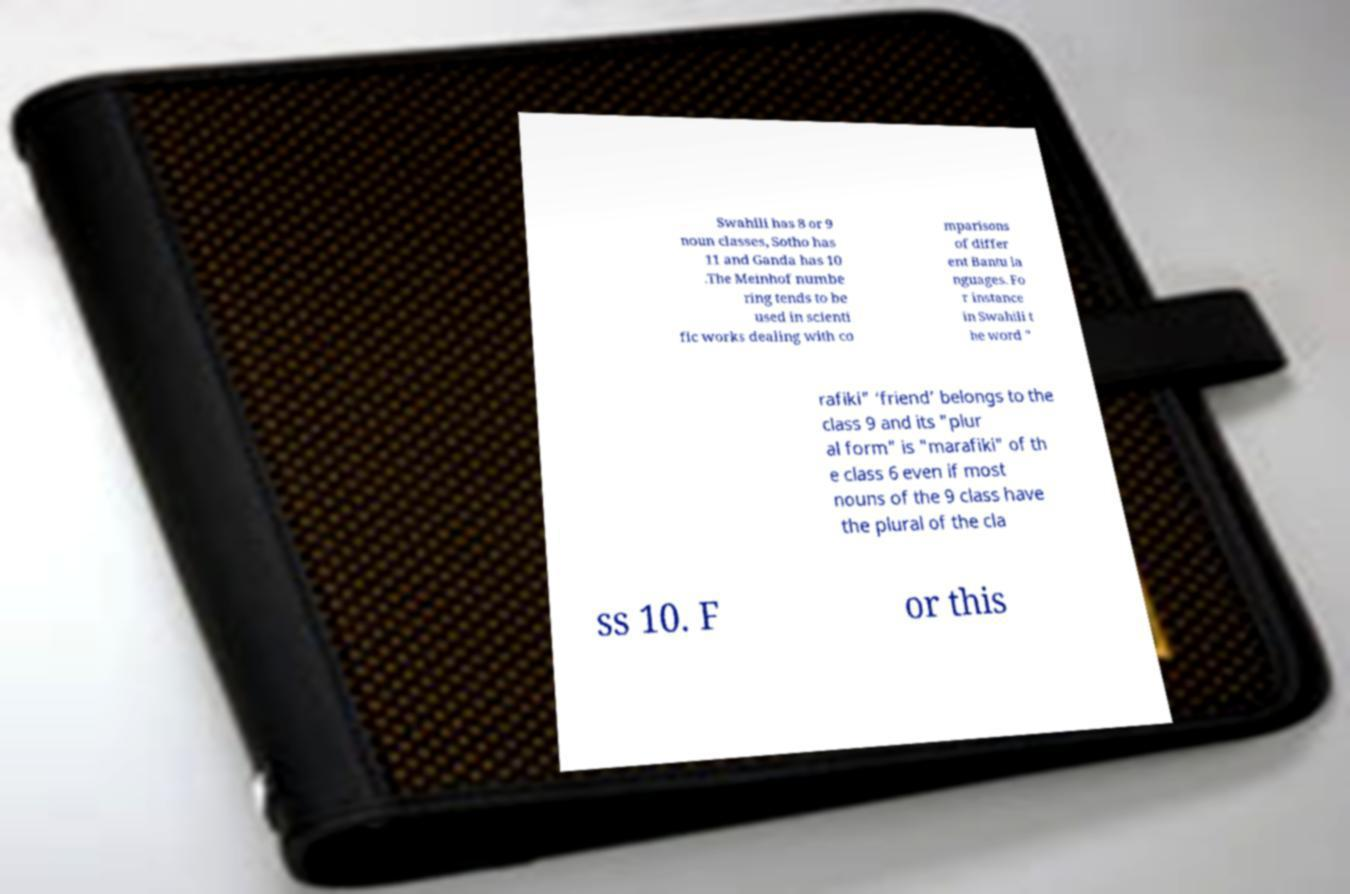Can you read and provide the text displayed in the image?This photo seems to have some interesting text. Can you extract and type it out for me? Swahili has 8 or 9 noun classes, Sotho has 11 and Ganda has 10 .The Meinhof numbe ring tends to be used in scienti fic works dealing with co mparisons of differ ent Bantu la nguages. Fo r instance in Swahili t he word " rafiki" ‘friend’ belongs to the class 9 and its "plur al form" is "marafiki" of th e class 6 even if most nouns of the 9 class have the plural of the cla ss 10. F or this 